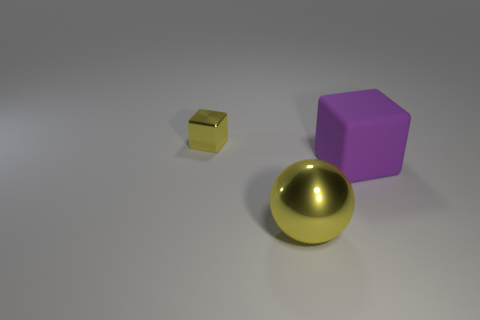Is the number of yellow objects greater than the number of objects?
Your answer should be very brief. No. There is another object that is the same color as the big shiny thing; what is its size?
Your answer should be very brief. Small. Are there any other tiny yellow things made of the same material as the small yellow object?
Ensure brevity in your answer.  No. There is a thing that is both to the left of the big matte thing and behind the ball; what is its shape?
Give a very brief answer. Cube. What number of other things are the same shape as the large yellow thing?
Your response must be concise. 0. What size is the yellow metal block?
Give a very brief answer. Small. What number of objects are either tiny yellow blocks or large green spheres?
Your answer should be very brief. 1. There is a metallic object on the left side of the big yellow ball; what is its size?
Keep it short and to the point. Small. Is there any other thing that has the same size as the yellow cube?
Ensure brevity in your answer.  No. There is a thing that is to the left of the large cube and right of the small yellow block; what is its color?
Give a very brief answer. Yellow. 